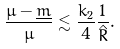<formula> <loc_0><loc_0><loc_500><loc_500>\frac { \mu - \underline { m } } { \mu } \lesssim \frac { k _ { 2 } } { 4 } \frac { 1 } { \hat { R } } .</formula> 